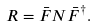<formula> <loc_0><loc_0><loc_500><loc_500>R = { \bar { F } } N { \bar { F } } ^ { \dagger } .</formula> 